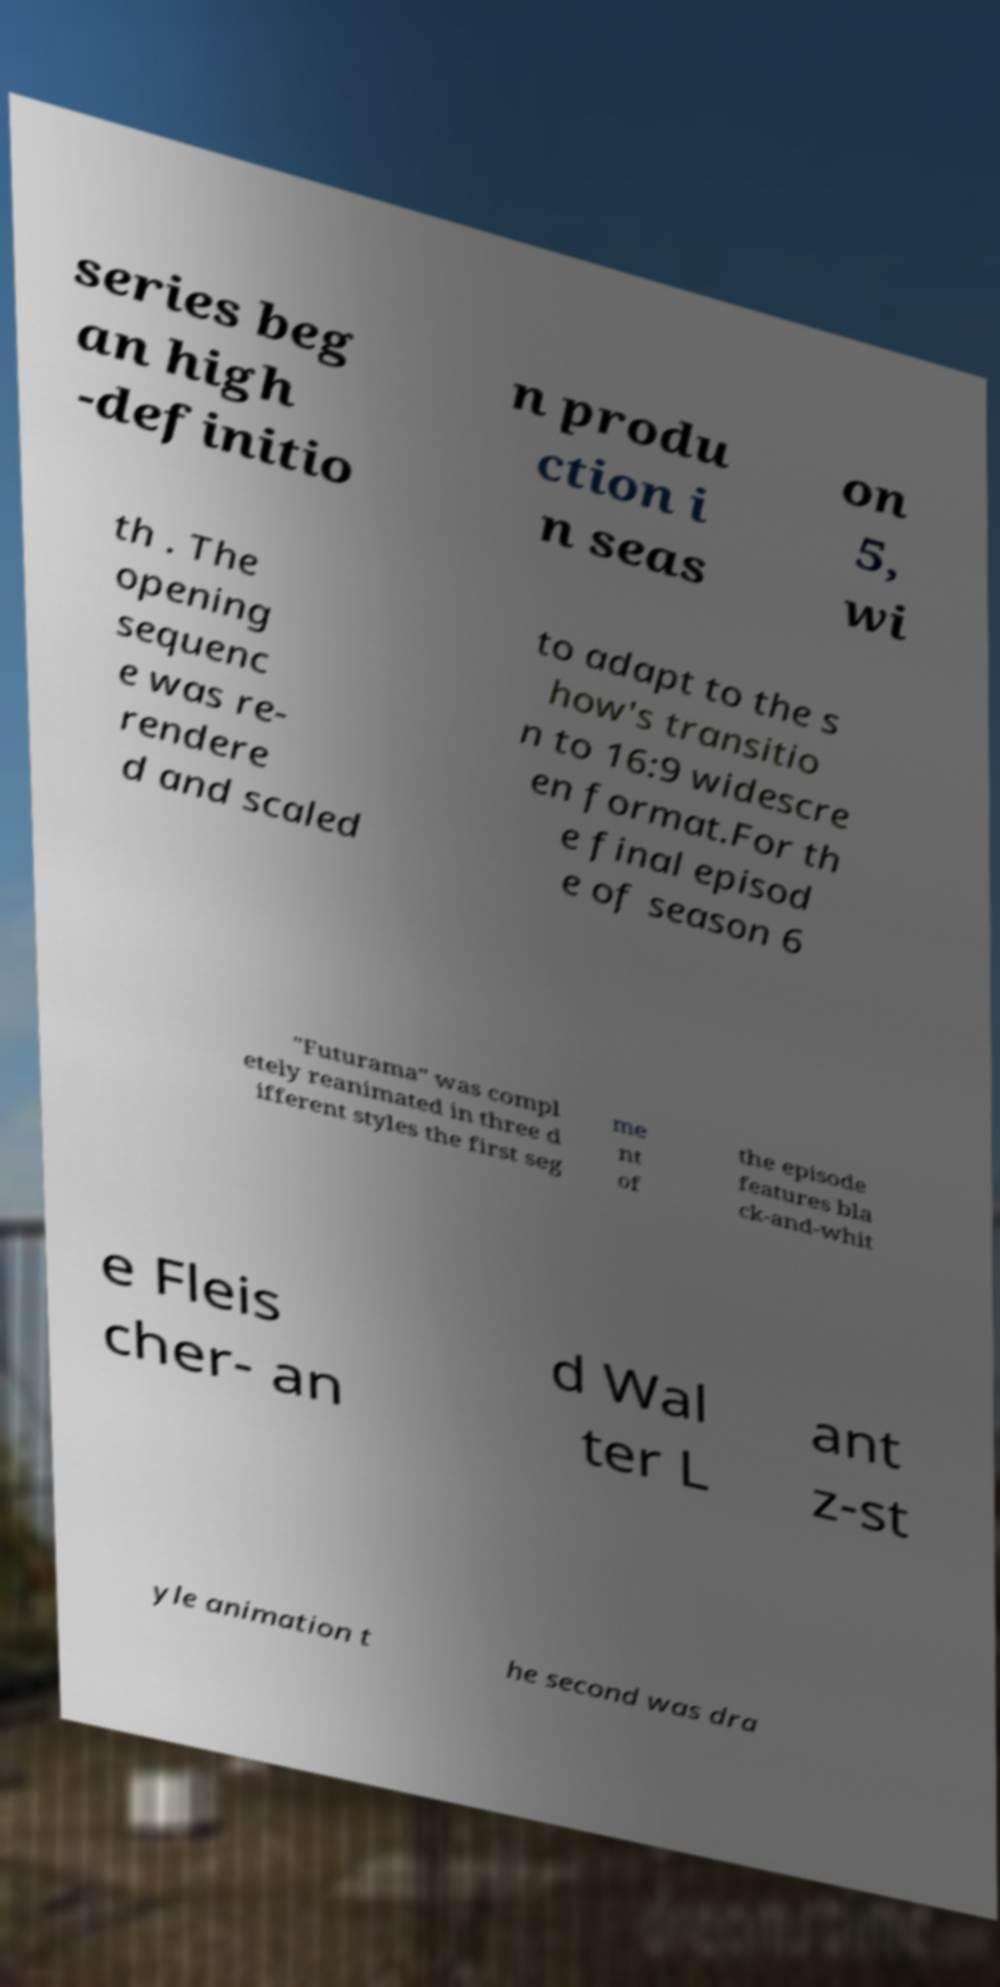I need the written content from this picture converted into text. Can you do that? series beg an high -definitio n produ ction i n seas on 5, wi th . The opening sequenc e was re- rendere d and scaled to adapt to the s how's transitio n to 16:9 widescre en format.For th e final episod e of season 6 "Futurama" was compl etely reanimated in three d ifferent styles the first seg me nt of the episode features bla ck-and-whit e Fleis cher- an d Wal ter L ant z-st yle animation t he second was dra 